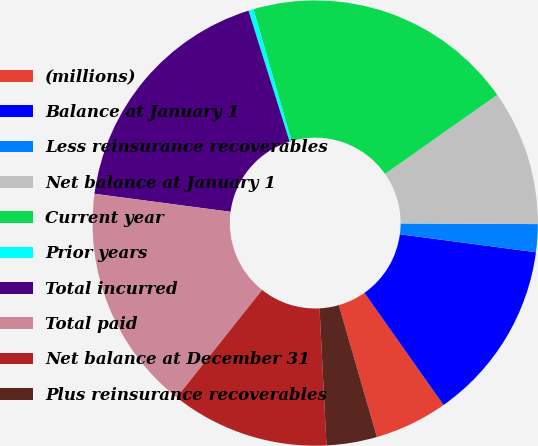Convert chart to OTSL. <chart><loc_0><loc_0><loc_500><loc_500><pie_chart><fcel>(millions)<fcel>Balance at January 1<fcel>Less reinsurance recoverables<fcel>Net balance at January 1<fcel>Current year<fcel>Prior years<fcel>Total incurred<fcel>Total paid<fcel>Net balance at December 31<fcel>Plus reinsurance recoverables<nl><fcel>5.31%<fcel>13.13%<fcel>2.02%<fcel>9.84%<fcel>19.71%<fcel>0.37%<fcel>18.06%<fcel>16.42%<fcel>11.49%<fcel>3.66%<nl></chart> 